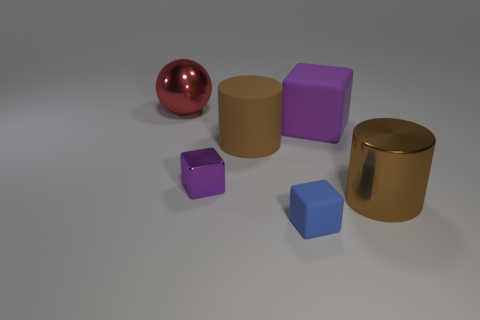There is a metal object behind the big brown cylinder that is behind the brown metallic cylinder; what color is it?
Offer a very short reply. Red. There is another thing that is the same shape as the brown metal thing; what size is it?
Ensure brevity in your answer.  Large. Do the big metal cylinder and the big matte cylinder have the same color?
Provide a succinct answer. Yes. What number of purple cubes are in front of the large matte object behind the brown cylinder that is behind the purple metallic object?
Your answer should be compact. 1. Are there more purple shiny things than big brown objects?
Your answer should be very brief. No. How many small cyan cylinders are there?
Provide a succinct answer. 0. What shape is the large shiny object to the left of the big cylinder on the left side of the large shiny thing in front of the big red ball?
Your answer should be compact. Sphere. Is the number of objects behind the big red object less than the number of purple things right of the small shiny thing?
Make the answer very short. Yes. Does the small object that is behind the metallic cylinder have the same shape as the big matte thing that is right of the tiny matte object?
Your answer should be very brief. Yes. There is a big brown thing that is to the left of the large shiny thing that is on the right side of the red thing; what shape is it?
Make the answer very short. Cylinder. 